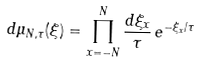Convert formula to latex. <formula><loc_0><loc_0><loc_500><loc_500>d \mu _ { N , \tau } ( \xi ) = \prod _ { x = - N } ^ { N } \frac { d \xi _ { x } } { \tau } \, e ^ { - \xi _ { x } / \tau }</formula> 